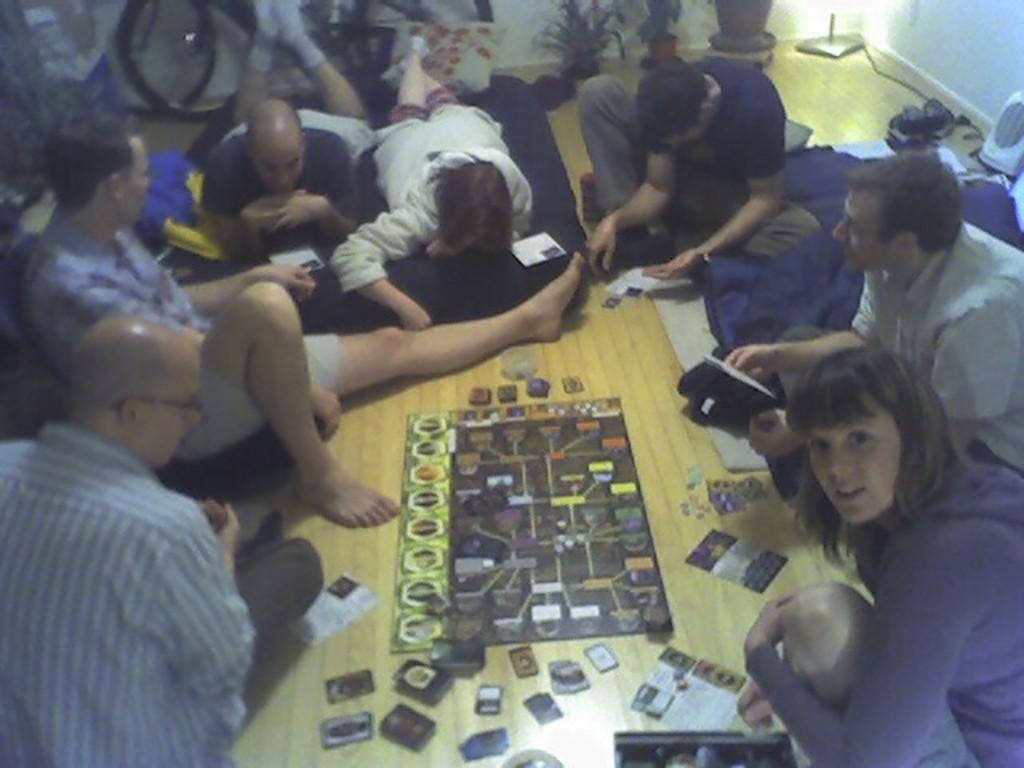What are the people in the image doing? The people in the image appear to be playing a game. How are the people positioned in the image? The people are sitting on the floor in the image. What other object can be seen in the image besides the people? There is a bicycle visible in the image. How much dust is visible on the bicycle in the image? There is no mention of dust in the image, and the bicycle does not appear to be dusty. How many people are in the crowd in the image? There is no crowd present in the image; it features a small group of people playing a game. 